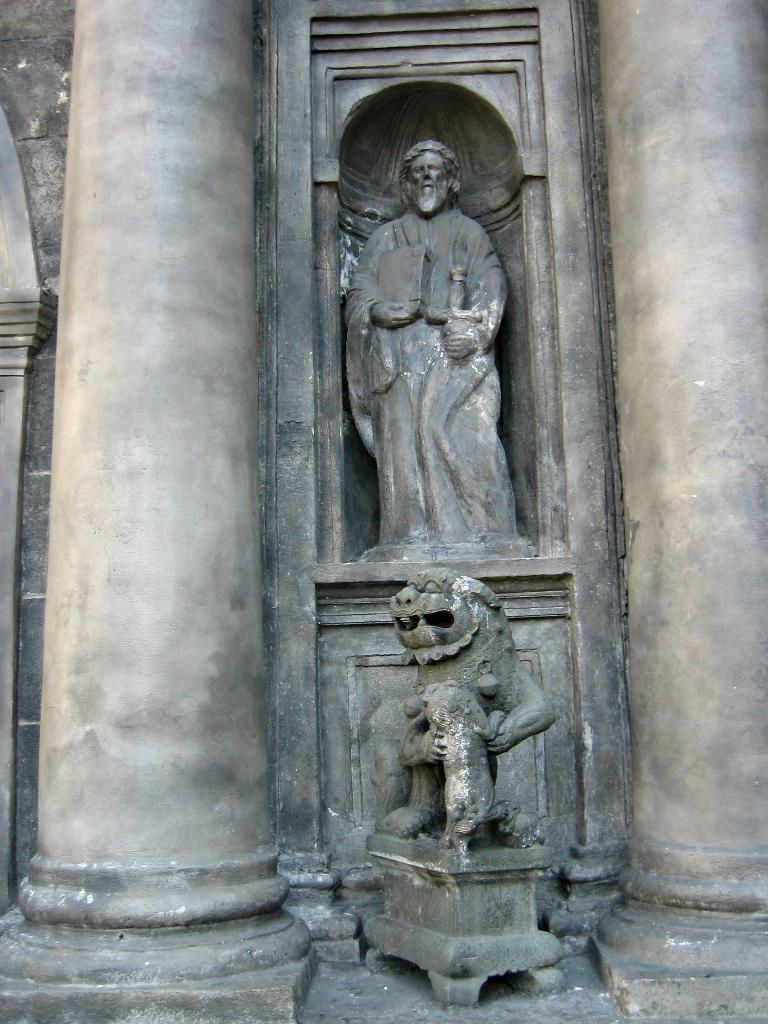Could you give a brief overview of what you see in this image? In this picture we can see pillars, wall and statues. 